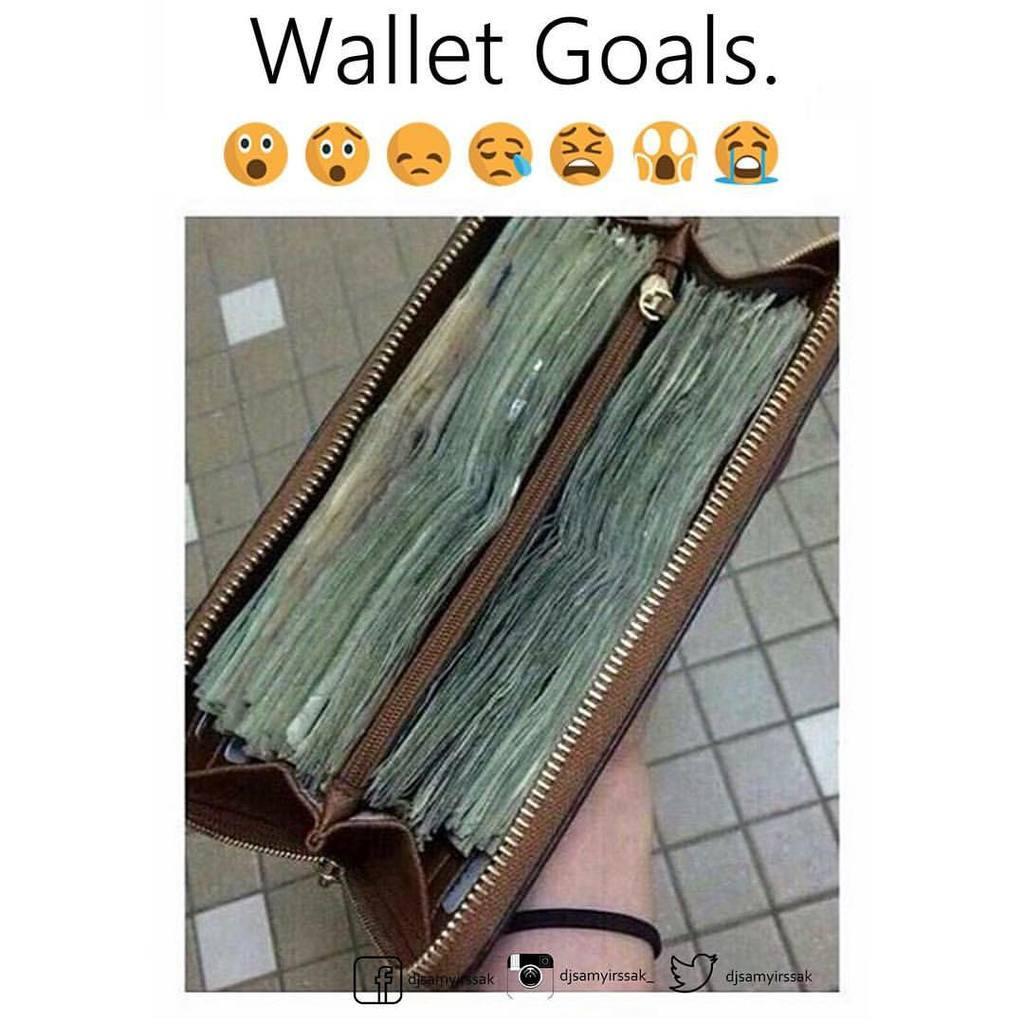How would you summarize this image in a sentence or two? In this image we can see a wallet. Behind the wallet tiles floor is present. At the top and bottom of the image we can see some text. 